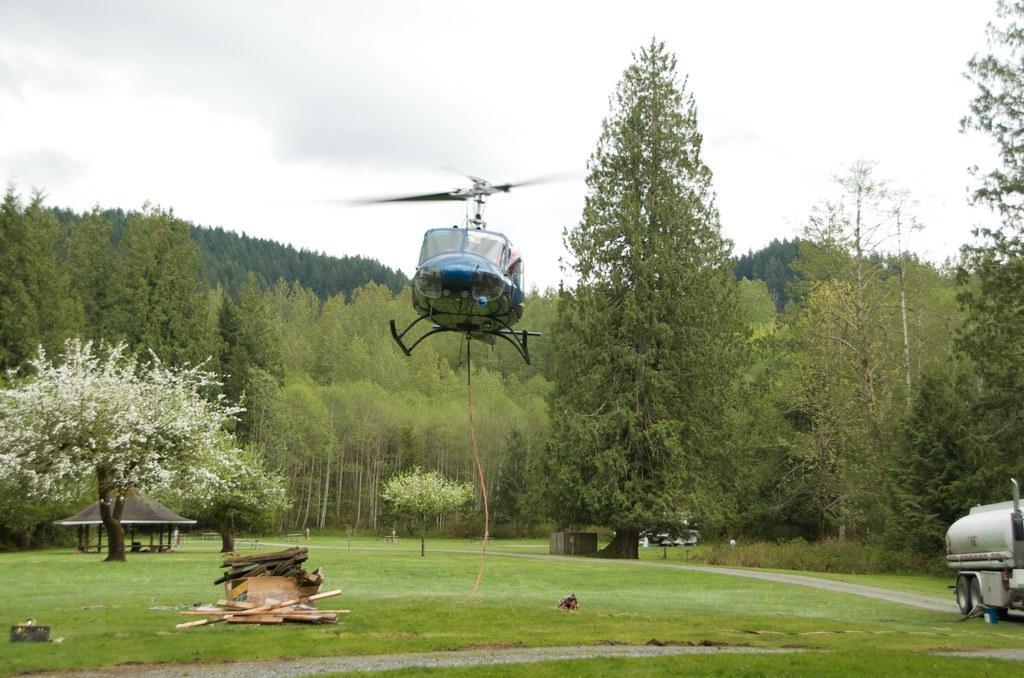In one or two sentences, can you explain what this image depicts? In this image I can see an aircraft which is in blue color. Background I can see trees in green color and sky in white color. 